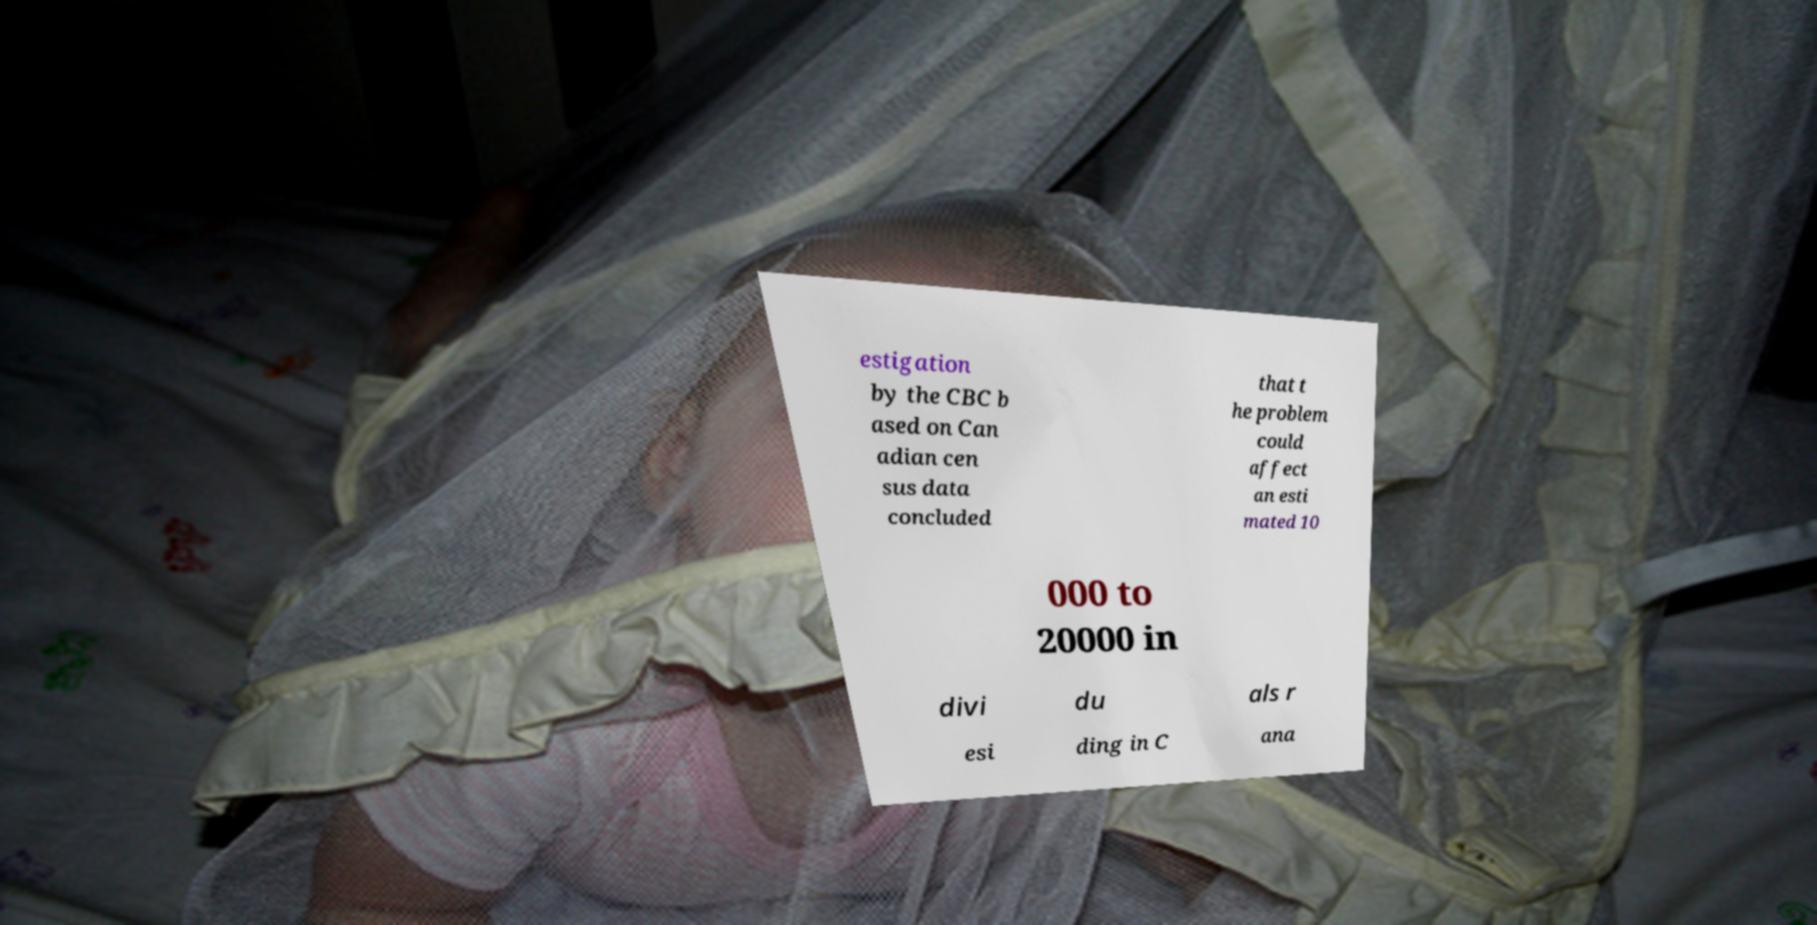Could you extract and type out the text from this image? estigation by the CBC b ased on Can adian cen sus data concluded that t he problem could affect an esti mated 10 000 to 20000 in divi du als r esi ding in C ana 